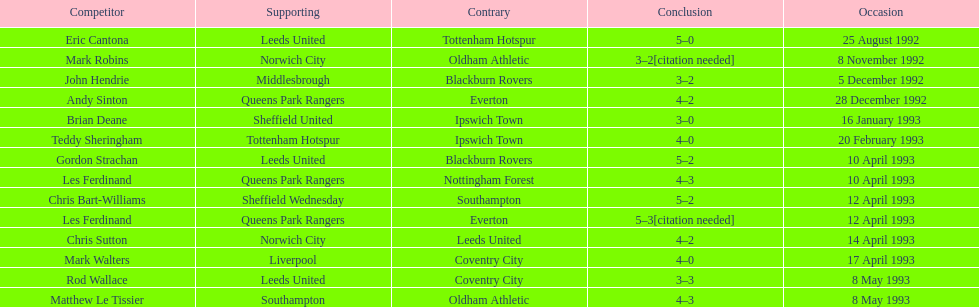Who does john hendrie play for? Middlesbrough. 